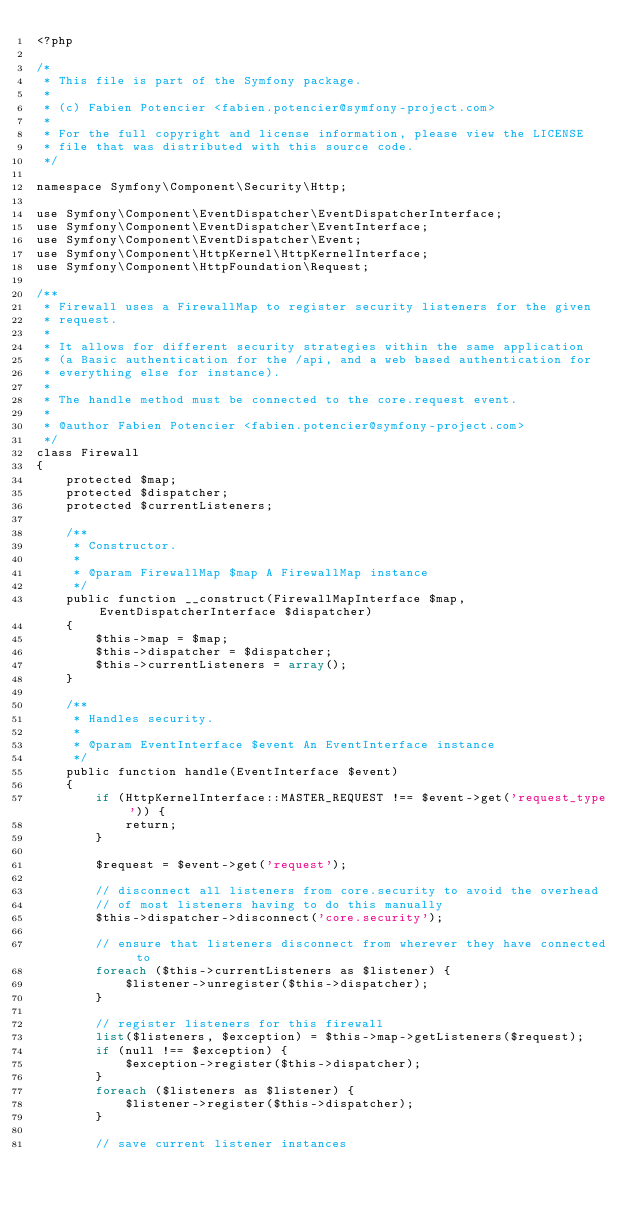Convert code to text. <code><loc_0><loc_0><loc_500><loc_500><_PHP_><?php

/*
 * This file is part of the Symfony package.
 *
 * (c) Fabien Potencier <fabien.potencier@symfony-project.com>
 *
 * For the full copyright and license information, please view the LICENSE
 * file that was distributed with this source code.
 */

namespace Symfony\Component\Security\Http;

use Symfony\Component\EventDispatcher\EventDispatcherInterface;
use Symfony\Component\EventDispatcher\EventInterface;
use Symfony\Component\EventDispatcher\Event;
use Symfony\Component\HttpKernel\HttpKernelInterface;
use Symfony\Component\HttpFoundation\Request;

/**
 * Firewall uses a FirewallMap to register security listeners for the given
 * request.
 *
 * It allows for different security strategies within the same application
 * (a Basic authentication for the /api, and a web based authentication for
 * everything else for instance).
 *
 * The handle method must be connected to the core.request event.
 *
 * @author Fabien Potencier <fabien.potencier@symfony-project.com>
 */
class Firewall
{
    protected $map;
    protected $dispatcher;
    protected $currentListeners;

    /**
     * Constructor.
     *
     * @param FirewallMap $map A FirewallMap instance
     */
    public function __construct(FirewallMapInterface $map, EventDispatcherInterface $dispatcher)
    {
        $this->map = $map;
        $this->dispatcher = $dispatcher;
        $this->currentListeners = array();
    }

    /**
     * Handles security.
     *
     * @param EventInterface $event An EventInterface instance
     */
    public function handle(EventInterface $event)
    {
        if (HttpKernelInterface::MASTER_REQUEST !== $event->get('request_type')) {
            return;
        }

        $request = $event->get('request');

        // disconnect all listeners from core.security to avoid the overhead
        // of most listeners having to do this manually
        $this->dispatcher->disconnect('core.security');

        // ensure that listeners disconnect from wherever they have connected to
        foreach ($this->currentListeners as $listener) {
            $listener->unregister($this->dispatcher);
        }

        // register listeners for this firewall
        list($listeners, $exception) = $this->map->getListeners($request);
        if (null !== $exception) {
            $exception->register($this->dispatcher);
        }
        foreach ($listeners as $listener) {
            $listener->register($this->dispatcher);
        }

        // save current listener instances</code> 